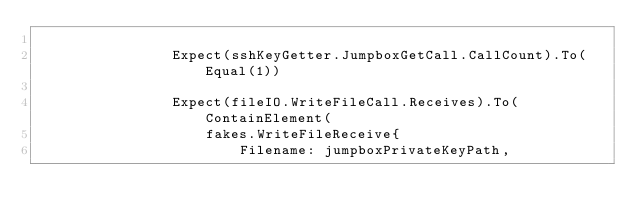<code> <loc_0><loc_0><loc_500><loc_500><_Go_>
				Expect(sshKeyGetter.JumpboxGetCall.CallCount).To(Equal(1))

				Expect(fileIO.WriteFileCall.Receives).To(ContainElement(
					fakes.WriteFileReceive{
						Filename: jumpboxPrivateKeyPath,</code> 